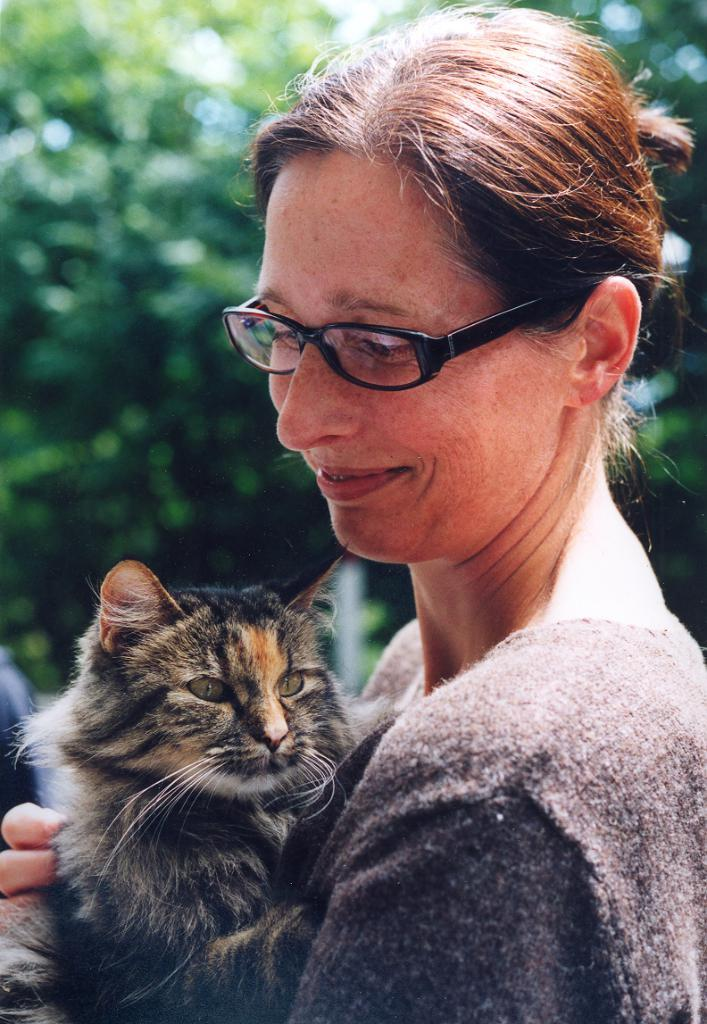Who is present in the image? There is a woman in the image. What is the woman doing in the image? The woman is smiling in the image. What is the woman holding in the image? The woman is holding a cat in the image. What can be seen in the background of the image? There are trees in the background of the image. What type of knee injury can be seen in the image? There is no knee injury present in the image; it features a woman holding a cat with trees in the background. Can you tell me how many cannons are visible in the image? There are no cannons present in the image. 